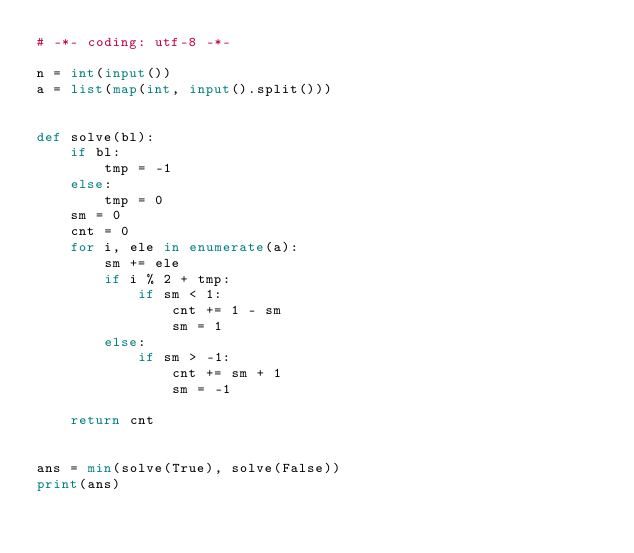<code> <loc_0><loc_0><loc_500><loc_500><_Python_># -*- coding: utf-8 -*-

n = int(input())
a = list(map(int, input().split()))


def solve(bl):
    if bl:
        tmp = -1
    else:
        tmp = 0
    sm = 0
    cnt = 0
    for i, ele in enumerate(a):
        sm += ele
        if i % 2 + tmp:
            if sm < 1:
                cnt += 1 - sm
                sm = 1
        else:
            if sm > -1:
                cnt += sm + 1
                sm = -1

    return cnt


ans = min(solve(True), solve(False))
print(ans)
</code> 